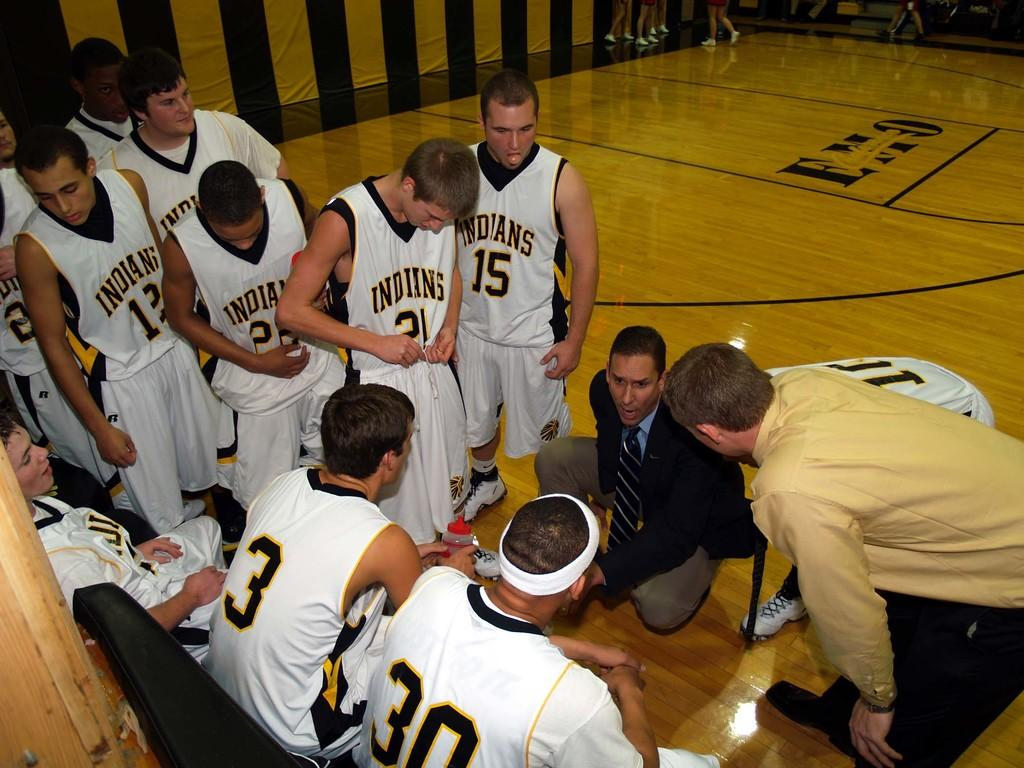<image>
Summarize the visual content of the image. Several basketball players with the team name Indians written on their shirts. 